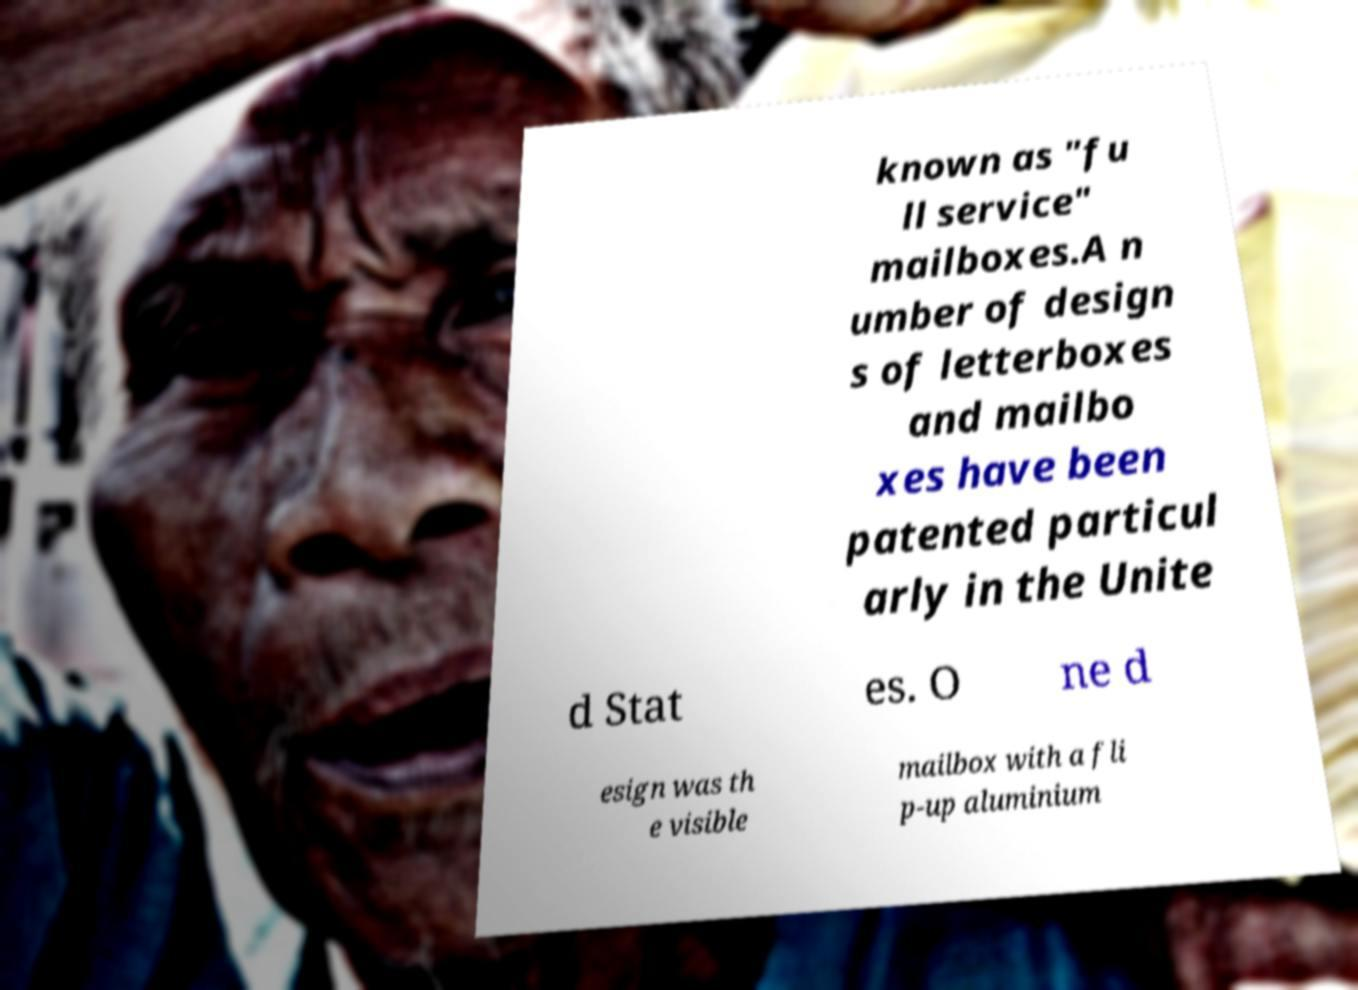Please read and relay the text visible in this image. What does it say? known as "fu ll service" mailboxes.A n umber of design s of letterboxes and mailbo xes have been patented particul arly in the Unite d Stat es. O ne d esign was th e visible mailbox with a fli p-up aluminium 